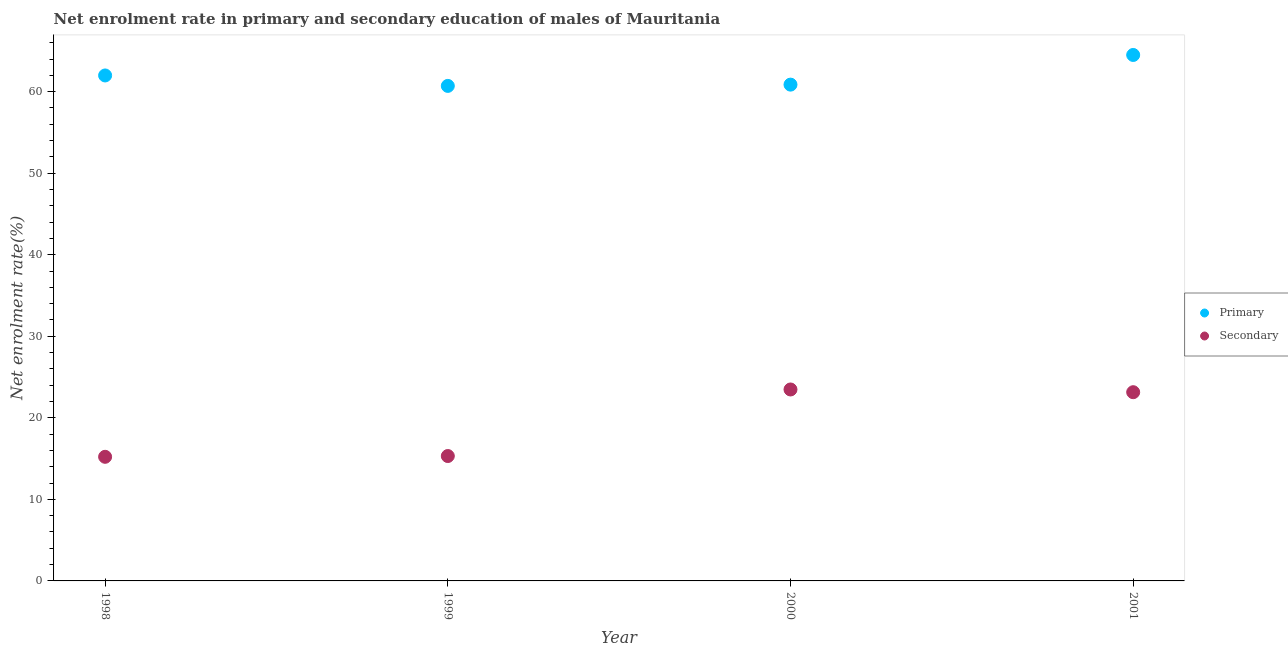Is the number of dotlines equal to the number of legend labels?
Your answer should be very brief. Yes. What is the enrollment rate in secondary education in 2000?
Make the answer very short. 23.48. Across all years, what is the maximum enrollment rate in primary education?
Make the answer very short. 64.5. Across all years, what is the minimum enrollment rate in primary education?
Give a very brief answer. 60.7. What is the total enrollment rate in primary education in the graph?
Offer a terse response. 248.04. What is the difference between the enrollment rate in primary education in 1999 and that in 2000?
Your answer should be compact. -0.16. What is the difference between the enrollment rate in secondary education in 1999 and the enrollment rate in primary education in 1998?
Your answer should be very brief. -46.67. What is the average enrollment rate in primary education per year?
Ensure brevity in your answer.  62.01. In the year 2000, what is the difference between the enrollment rate in primary education and enrollment rate in secondary education?
Give a very brief answer. 37.38. In how many years, is the enrollment rate in secondary education greater than 2 %?
Offer a terse response. 4. What is the ratio of the enrollment rate in primary education in 1999 to that in 2001?
Offer a terse response. 0.94. What is the difference between the highest and the second highest enrollment rate in primary education?
Ensure brevity in your answer.  2.51. What is the difference between the highest and the lowest enrollment rate in secondary education?
Give a very brief answer. 8.26. Is the sum of the enrollment rate in primary education in 1998 and 2000 greater than the maximum enrollment rate in secondary education across all years?
Keep it short and to the point. Yes. Is the enrollment rate in primary education strictly greater than the enrollment rate in secondary education over the years?
Your answer should be compact. Yes. How many years are there in the graph?
Your response must be concise. 4. What is the difference between two consecutive major ticks on the Y-axis?
Provide a short and direct response. 10. Are the values on the major ticks of Y-axis written in scientific E-notation?
Your answer should be compact. No. Does the graph contain grids?
Give a very brief answer. No. How are the legend labels stacked?
Give a very brief answer. Vertical. What is the title of the graph?
Your answer should be compact. Net enrolment rate in primary and secondary education of males of Mauritania. What is the label or title of the Y-axis?
Provide a short and direct response. Net enrolment rate(%). What is the Net enrolment rate(%) of Primary in 1998?
Provide a short and direct response. 61.98. What is the Net enrolment rate(%) in Secondary in 1998?
Provide a succinct answer. 15.22. What is the Net enrolment rate(%) of Primary in 1999?
Your response must be concise. 60.7. What is the Net enrolment rate(%) of Secondary in 1999?
Offer a terse response. 15.31. What is the Net enrolment rate(%) of Primary in 2000?
Provide a succinct answer. 60.86. What is the Net enrolment rate(%) of Secondary in 2000?
Your response must be concise. 23.48. What is the Net enrolment rate(%) in Primary in 2001?
Keep it short and to the point. 64.5. What is the Net enrolment rate(%) of Secondary in 2001?
Provide a succinct answer. 23.14. Across all years, what is the maximum Net enrolment rate(%) of Primary?
Provide a succinct answer. 64.5. Across all years, what is the maximum Net enrolment rate(%) in Secondary?
Make the answer very short. 23.48. Across all years, what is the minimum Net enrolment rate(%) in Primary?
Your answer should be compact. 60.7. Across all years, what is the minimum Net enrolment rate(%) of Secondary?
Offer a very short reply. 15.22. What is the total Net enrolment rate(%) of Primary in the graph?
Keep it short and to the point. 248.04. What is the total Net enrolment rate(%) in Secondary in the graph?
Offer a very short reply. 77.15. What is the difference between the Net enrolment rate(%) of Primary in 1998 and that in 1999?
Provide a short and direct response. 1.28. What is the difference between the Net enrolment rate(%) of Secondary in 1998 and that in 1999?
Your answer should be very brief. -0.1. What is the difference between the Net enrolment rate(%) in Primary in 1998 and that in 2000?
Your answer should be compact. 1.12. What is the difference between the Net enrolment rate(%) of Secondary in 1998 and that in 2000?
Offer a terse response. -8.26. What is the difference between the Net enrolment rate(%) of Primary in 1998 and that in 2001?
Ensure brevity in your answer.  -2.51. What is the difference between the Net enrolment rate(%) in Secondary in 1998 and that in 2001?
Give a very brief answer. -7.92. What is the difference between the Net enrolment rate(%) of Primary in 1999 and that in 2000?
Offer a terse response. -0.16. What is the difference between the Net enrolment rate(%) of Secondary in 1999 and that in 2000?
Your response must be concise. -8.16. What is the difference between the Net enrolment rate(%) in Primary in 1999 and that in 2001?
Provide a short and direct response. -3.79. What is the difference between the Net enrolment rate(%) of Secondary in 1999 and that in 2001?
Provide a succinct answer. -7.83. What is the difference between the Net enrolment rate(%) of Primary in 2000 and that in 2001?
Ensure brevity in your answer.  -3.64. What is the difference between the Net enrolment rate(%) of Secondary in 2000 and that in 2001?
Offer a very short reply. 0.33. What is the difference between the Net enrolment rate(%) in Primary in 1998 and the Net enrolment rate(%) in Secondary in 1999?
Provide a short and direct response. 46.67. What is the difference between the Net enrolment rate(%) in Primary in 1998 and the Net enrolment rate(%) in Secondary in 2000?
Ensure brevity in your answer.  38.51. What is the difference between the Net enrolment rate(%) of Primary in 1998 and the Net enrolment rate(%) of Secondary in 2001?
Provide a short and direct response. 38.84. What is the difference between the Net enrolment rate(%) of Primary in 1999 and the Net enrolment rate(%) of Secondary in 2000?
Ensure brevity in your answer.  37.23. What is the difference between the Net enrolment rate(%) of Primary in 1999 and the Net enrolment rate(%) of Secondary in 2001?
Offer a terse response. 37.56. What is the difference between the Net enrolment rate(%) in Primary in 2000 and the Net enrolment rate(%) in Secondary in 2001?
Your answer should be very brief. 37.72. What is the average Net enrolment rate(%) of Primary per year?
Your response must be concise. 62.01. What is the average Net enrolment rate(%) of Secondary per year?
Provide a short and direct response. 19.29. In the year 1998, what is the difference between the Net enrolment rate(%) in Primary and Net enrolment rate(%) in Secondary?
Offer a very short reply. 46.76. In the year 1999, what is the difference between the Net enrolment rate(%) in Primary and Net enrolment rate(%) in Secondary?
Keep it short and to the point. 45.39. In the year 2000, what is the difference between the Net enrolment rate(%) of Primary and Net enrolment rate(%) of Secondary?
Make the answer very short. 37.38. In the year 2001, what is the difference between the Net enrolment rate(%) of Primary and Net enrolment rate(%) of Secondary?
Your answer should be compact. 41.35. What is the ratio of the Net enrolment rate(%) of Primary in 1998 to that in 1999?
Provide a short and direct response. 1.02. What is the ratio of the Net enrolment rate(%) of Secondary in 1998 to that in 1999?
Give a very brief answer. 0.99. What is the ratio of the Net enrolment rate(%) in Primary in 1998 to that in 2000?
Your response must be concise. 1.02. What is the ratio of the Net enrolment rate(%) of Secondary in 1998 to that in 2000?
Your answer should be compact. 0.65. What is the ratio of the Net enrolment rate(%) in Primary in 1998 to that in 2001?
Ensure brevity in your answer.  0.96. What is the ratio of the Net enrolment rate(%) in Secondary in 1998 to that in 2001?
Provide a short and direct response. 0.66. What is the ratio of the Net enrolment rate(%) in Primary in 1999 to that in 2000?
Your answer should be compact. 1. What is the ratio of the Net enrolment rate(%) of Secondary in 1999 to that in 2000?
Give a very brief answer. 0.65. What is the ratio of the Net enrolment rate(%) in Secondary in 1999 to that in 2001?
Provide a succinct answer. 0.66. What is the ratio of the Net enrolment rate(%) of Primary in 2000 to that in 2001?
Offer a terse response. 0.94. What is the ratio of the Net enrolment rate(%) of Secondary in 2000 to that in 2001?
Ensure brevity in your answer.  1.01. What is the difference between the highest and the second highest Net enrolment rate(%) of Primary?
Keep it short and to the point. 2.51. What is the difference between the highest and the second highest Net enrolment rate(%) in Secondary?
Your answer should be compact. 0.33. What is the difference between the highest and the lowest Net enrolment rate(%) in Primary?
Ensure brevity in your answer.  3.79. What is the difference between the highest and the lowest Net enrolment rate(%) of Secondary?
Keep it short and to the point. 8.26. 